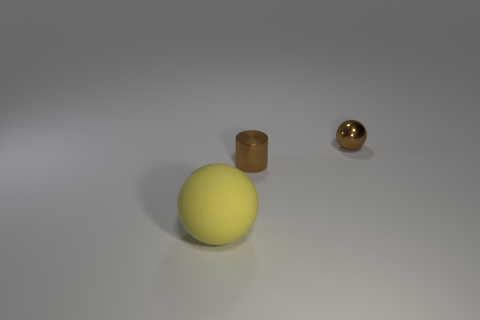There is a tiny metallic thing that is to the right of the brown cylinder; is it the same shape as the brown shiny thing on the left side of the brown sphere?
Your response must be concise. No. There is a metallic cylinder that is to the left of the ball on the right side of the matte sphere; what color is it?
Your answer should be very brief. Brown. How many balls are small red objects or yellow things?
Your answer should be compact. 1. There is a small metallic object that is in front of the sphere behind the big object; how many things are to the right of it?
Your response must be concise. 1. What is the size of the ball that is the same color as the shiny cylinder?
Offer a very short reply. Small. Are there any large red cylinders made of the same material as the tiny brown cylinder?
Your answer should be compact. No. Is the yellow sphere made of the same material as the tiny sphere?
Give a very brief answer. No. How many metal objects are behind the sphere that is to the right of the yellow ball?
Your answer should be compact. 0. What number of blue things are either large matte cubes or metal spheres?
Offer a very short reply. 0. There is a thing that is behind the small brown thing left of the ball to the right of the matte ball; what is its shape?
Your answer should be very brief. Sphere. 